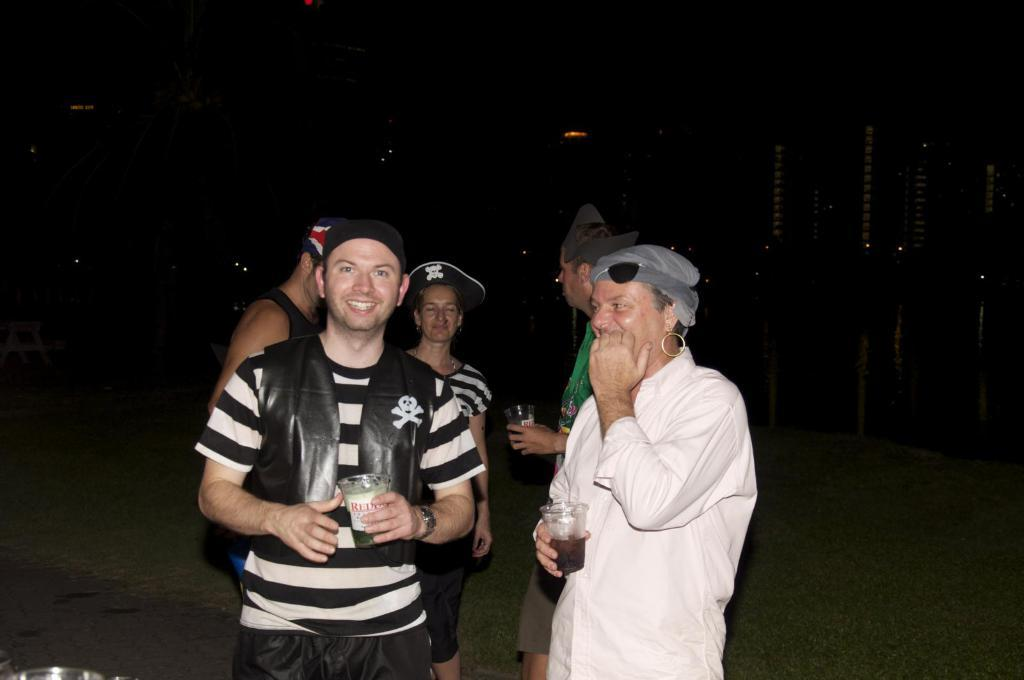How many individuals are present in the image? There are many people in the image. What type of headwear are the people wearing? The people are wearing caps. Can you describe the background of the image? The background of the image is dark. What type of journey are the people embarking on in the image? There is no indication of a journey in the image; it only shows people wearing caps with a dark background. Can you identify any friends among the people in the image? The image does not provide information about friendships or relationships between the people. 